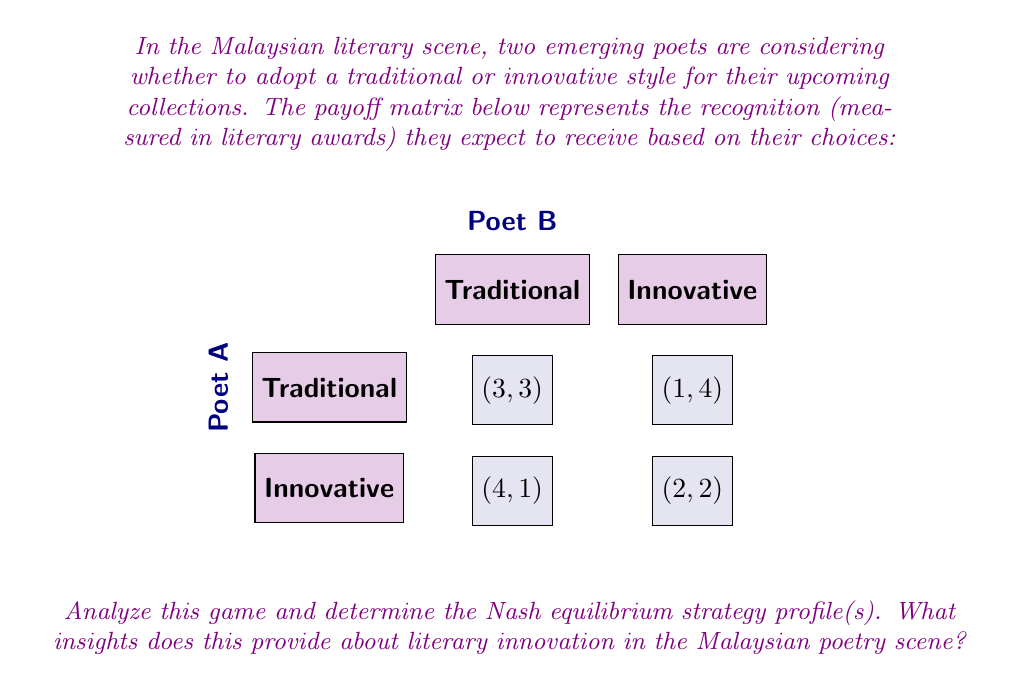Give your solution to this math problem. To solve this game theory problem, we'll follow these steps:

1) First, let's identify the best responses for each player:

   For Poet A:
   - If Poet B chooses Traditional, Poet A's best response is Innovative (4 > 3)
   - If Poet B chooses Innovative, Poet A's best response is Traditional (1 > 2)

   For Poet B:
   - If Poet A chooses Traditional, Poet B's best response is Innovative (4 > 3)
   - If Poet A chooses Innovative, Poet B's best response is Traditional (2 > 1)

2) A Nash equilibrium occurs when each player's strategy is the best response to the other player's strategy. From our analysis, we can see that there is no pure strategy Nash equilibrium, as no cell in the payoff matrix satisfies both players' best responses simultaneously.

3) Therefore, we need to look for a mixed strategy equilibrium. Let's define:
   $p$ = probability that Poet A chooses Traditional
   $q$ = probability that Poet B chooses Traditional

4) For a mixed strategy equilibrium, each player must be indifferent between their two strategies. This gives us two equations:

   For Poet A: $3q + 1(1-q) = 4q + 2(1-q)$
   For Poet B: $3p + 4(1-p) = p + 2(1-p)$

5) Solving these equations:
   
   From Poet A's equation: $3q + 1 - q = 4q + 2 - 2q$
                           $2q + 1 = 2q + 2$
                           $1 = 1$
   This is always true, so Poet B's strategy doesn't affect Poet A's payoff.

   From Poet B's equation: $3p + 4 - 4p = p + 2 - 2p$
                           $-p + 4 = -p + 2$
                           $2 = 0$
   This is never true, indicating that Poet A must use a pure strategy.

6) Since Poet A must use a pure strategy and we know there's no pure strategy equilibrium, Poet A must be indifferent between their strategies. This occurs when:

   $3q + 1(1-q) = 4q + 2(1-q)$
   $3q + 1 - q = 4q + 2 - 2q$
   $2q + 1 = 2q + 2$
   $1 = 1$

   This is always true, so Poet B can choose any probability $q$.

7) For Poet A to be indifferent, Poet B must choose $q$ such that:
   
   $3q + 1(1-q) = 4q + 2(1-q)$
   $3q + 1 - q = 4q + 2 - 2q$
   $2q + 1 = 2q + 2$
   $q = 1/2$

Therefore, the mixed strategy Nash equilibrium is:
- Poet A chooses Innovative with probability 1
- Poet B chooses Traditional with probability 1/2 and Innovative with probability 1/2

This equilibrium suggests that in the Malaysian poetry scene, one strategy for gaining recognition is to consistently innovate, while others may benefit from alternating between traditional and innovative styles.
Answer: (Innovative, 1/2 Traditional + 1/2 Innovative) 